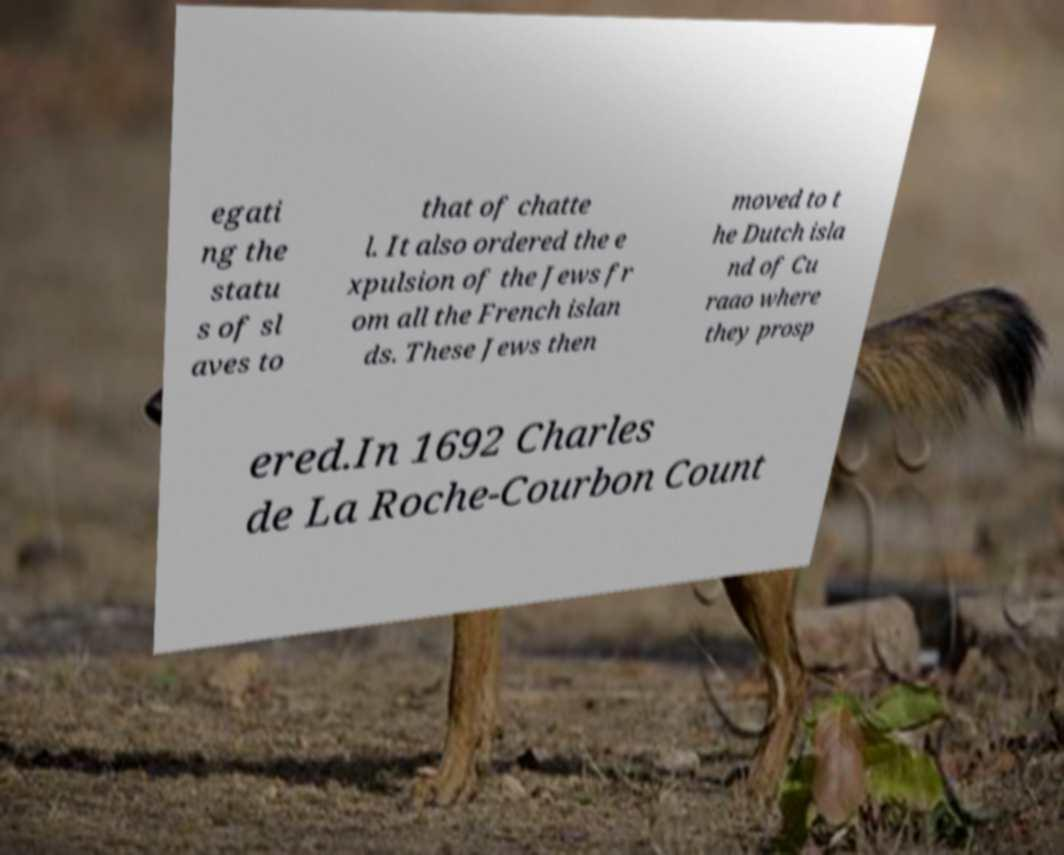There's text embedded in this image that I need extracted. Can you transcribe it verbatim? egati ng the statu s of sl aves to that of chatte l. It also ordered the e xpulsion of the Jews fr om all the French islan ds. These Jews then moved to t he Dutch isla nd of Cu raao where they prosp ered.In 1692 Charles de La Roche-Courbon Count 